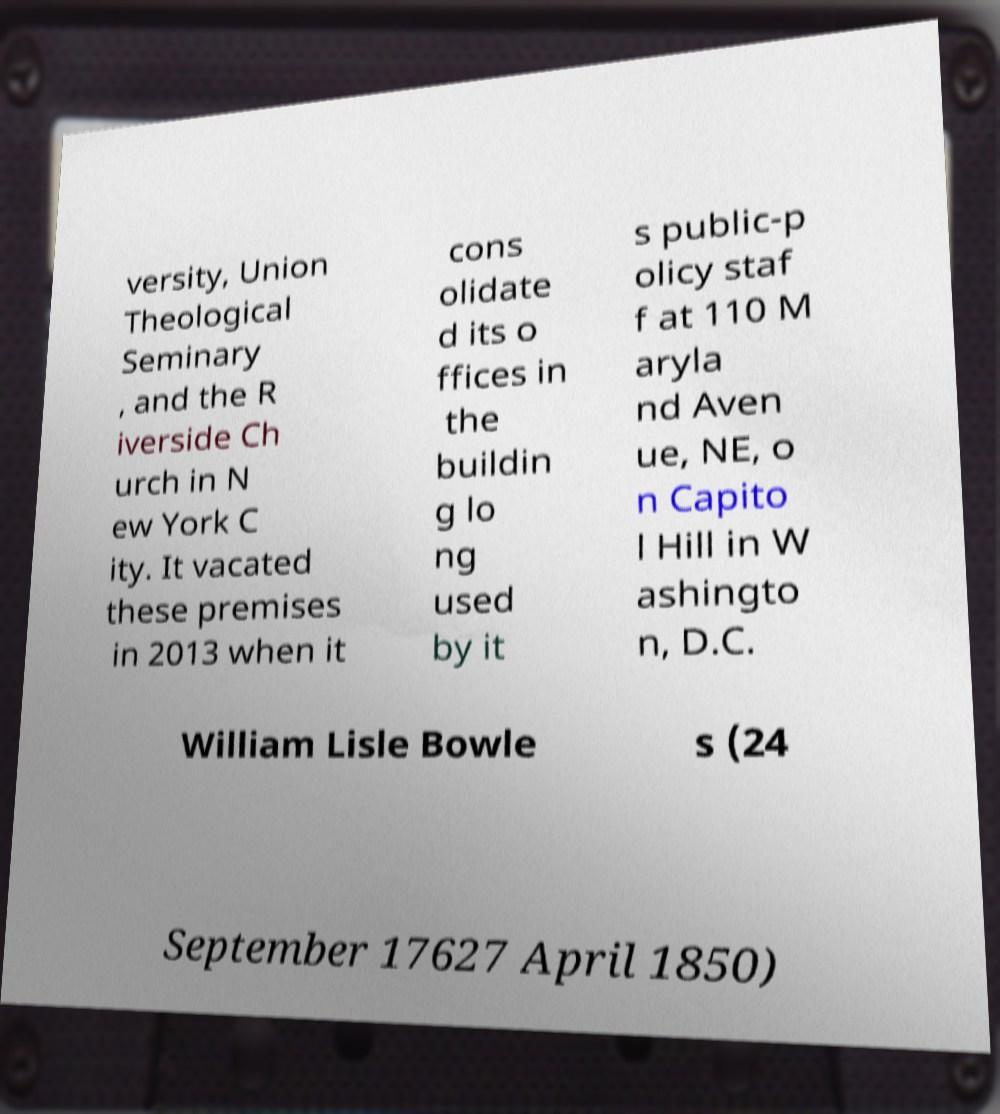Please read and relay the text visible in this image. What does it say? versity, Union Theological Seminary , and the R iverside Ch urch in N ew York C ity. It vacated these premises in 2013 when it cons olidate d its o ffices in the buildin g lo ng used by it s public-p olicy staf f at 110 M aryla nd Aven ue, NE, o n Capito l Hill in W ashingto n, D.C. William Lisle Bowle s (24 September 17627 April 1850) 